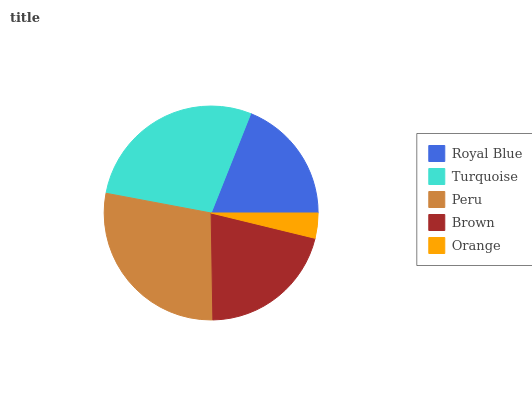Is Orange the minimum?
Answer yes or no. Yes. Is Peru the maximum?
Answer yes or no. Yes. Is Turquoise the minimum?
Answer yes or no. No. Is Turquoise the maximum?
Answer yes or no. No. Is Turquoise greater than Royal Blue?
Answer yes or no. Yes. Is Royal Blue less than Turquoise?
Answer yes or no. Yes. Is Royal Blue greater than Turquoise?
Answer yes or no. No. Is Turquoise less than Royal Blue?
Answer yes or no. No. Is Brown the high median?
Answer yes or no. Yes. Is Brown the low median?
Answer yes or no. Yes. Is Turquoise the high median?
Answer yes or no. No. Is Orange the low median?
Answer yes or no. No. 